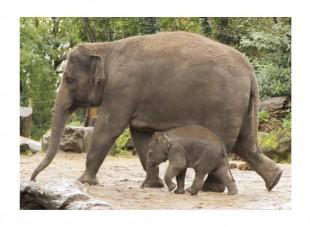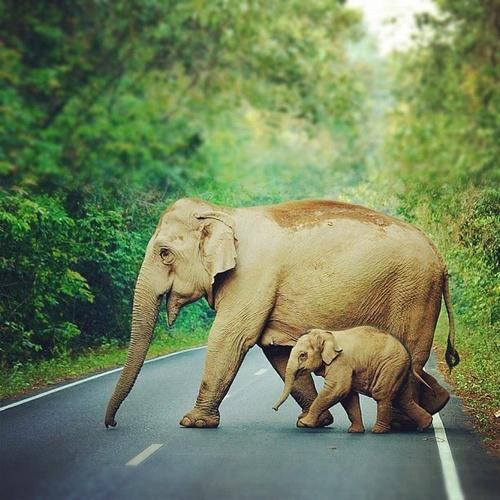The first image is the image on the left, the second image is the image on the right. For the images shown, is this caption "In each image, at the side of an adult elephant is a baby elephant, approximately tall enough to reach the underside of the adult's belly area." true? Answer yes or no. Yes. The first image is the image on the left, the second image is the image on the right. Examine the images to the left and right. Is the description "An image shows just one adult elephant interacting with a baby elephant on bright green grass." accurate? Answer yes or no. No. 